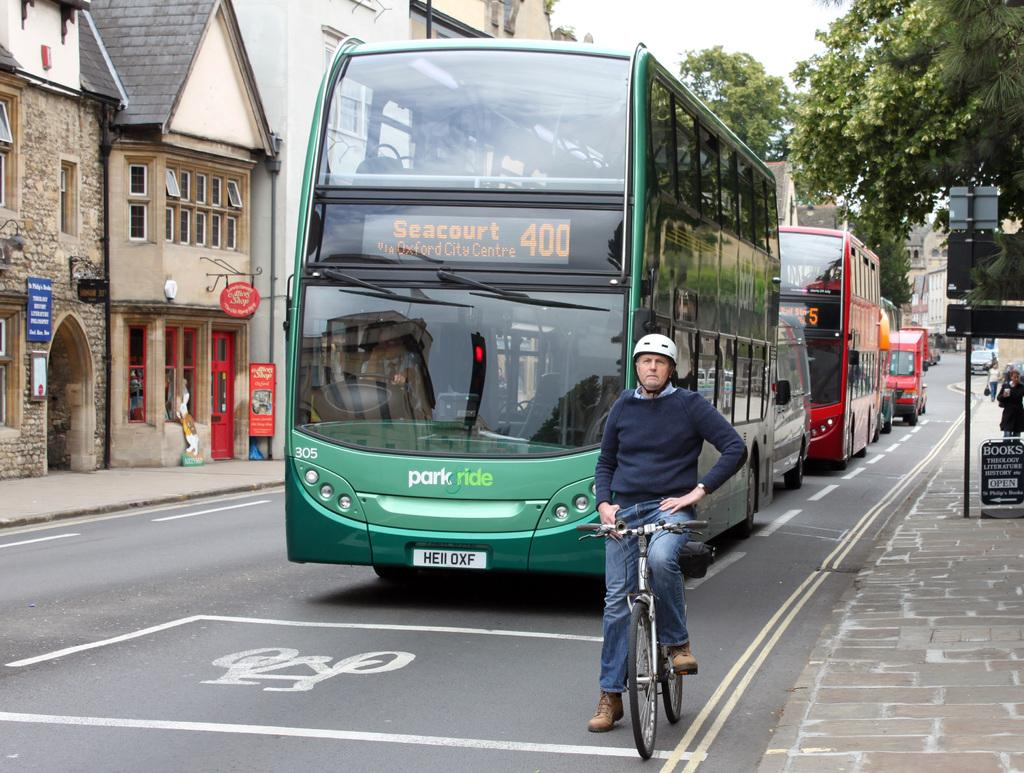What is the person in the image doing? The person is sitting on a bicycle on the road. What can be seen behind the person on the bicycle? There are buses behind the person on the bicycle. What type of vegetation is visible in the image? There are trees at the right side of the image. What type of structures are visible in the image? There are buildings at the left side of the image. What color is the paint on the visitor's shirt in the image? There is no visitor present in the image, and therefore no shirt or paint to describe. 